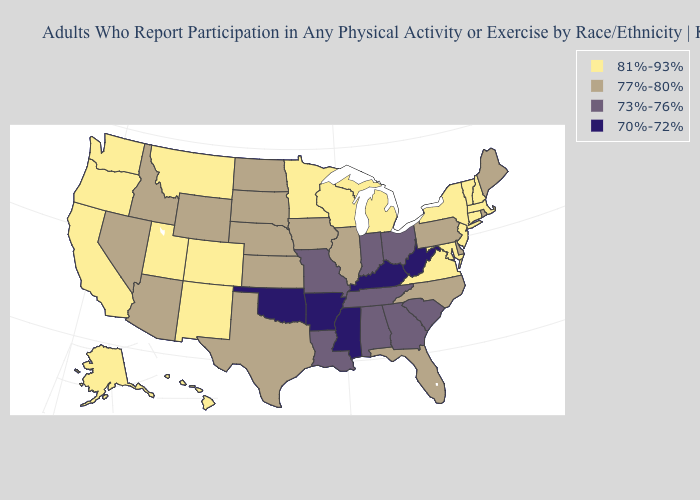What is the value of Montana?
Keep it brief. 81%-93%. Name the states that have a value in the range 70%-72%?
Short answer required. Arkansas, Kentucky, Mississippi, Oklahoma, West Virginia. Name the states that have a value in the range 77%-80%?
Be succinct. Arizona, Delaware, Florida, Idaho, Illinois, Iowa, Kansas, Maine, Nebraska, Nevada, North Carolina, North Dakota, Pennsylvania, Rhode Island, South Dakota, Texas, Wyoming. What is the value of North Carolina?
Answer briefly. 77%-80%. Name the states that have a value in the range 70%-72%?
Give a very brief answer. Arkansas, Kentucky, Mississippi, Oklahoma, West Virginia. Which states have the lowest value in the USA?
Be succinct. Arkansas, Kentucky, Mississippi, Oklahoma, West Virginia. Does Mississippi have a higher value than New Hampshire?
Write a very short answer. No. What is the value of Montana?
Be succinct. 81%-93%. Which states have the lowest value in the South?
Concise answer only. Arkansas, Kentucky, Mississippi, Oklahoma, West Virginia. Which states hav the highest value in the Northeast?
Be succinct. Connecticut, Massachusetts, New Hampshire, New Jersey, New York, Vermont. Is the legend a continuous bar?
Quick response, please. No. What is the highest value in states that border Illinois?
Answer briefly. 81%-93%. What is the value of California?
Short answer required. 81%-93%. What is the highest value in the USA?
Quick response, please. 81%-93%. Does Wisconsin have a higher value than Alabama?
Give a very brief answer. Yes. 